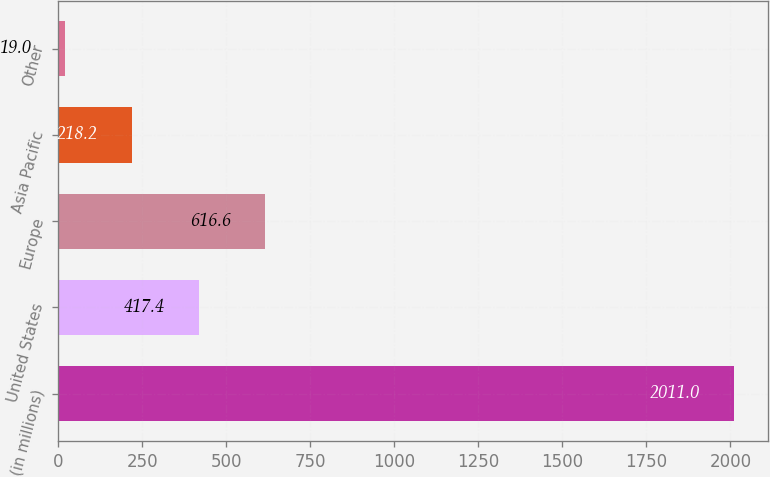Convert chart. <chart><loc_0><loc_0><loc_500><loc_500><bar_chart><fcel>(in millions)<fcel>United States<fcel>Europe<fcel>Asia Pacific<fcel>Other<nl><fcel>2011<fcel>417.4<fcel>616.6<fcel>218.2<fcel>19<nl></chart> 